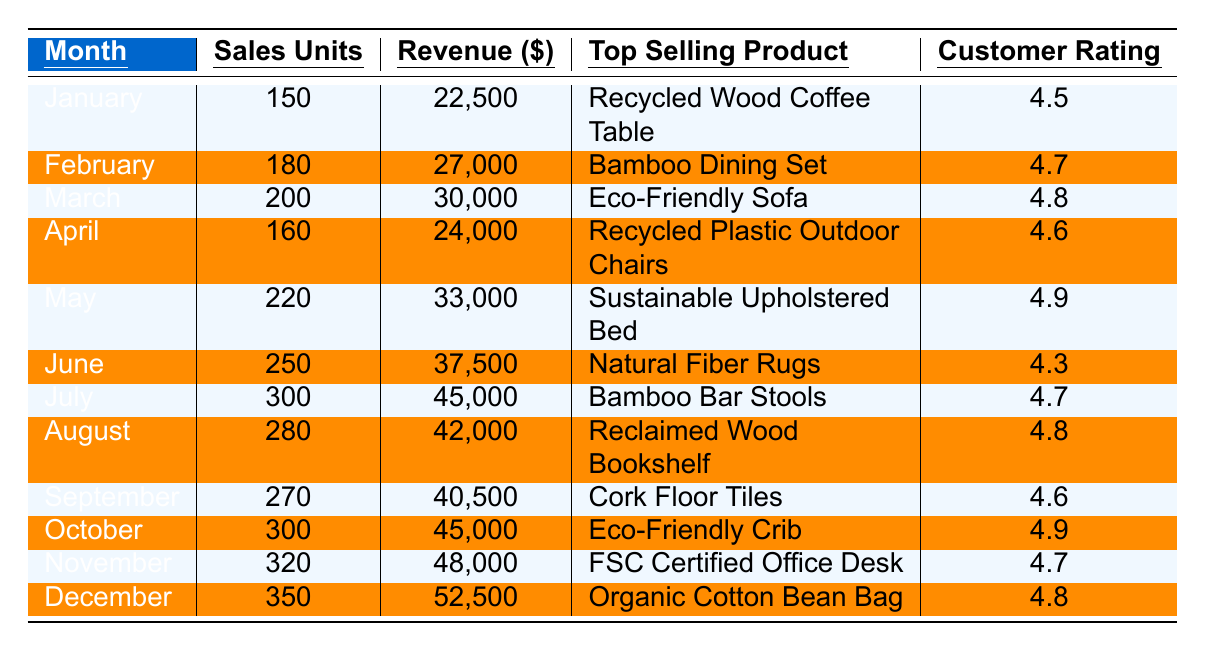What was the top-selling product in December? In December, the top-selling product listed in the table is the "Organic Cotton Bean Bag."
Answer: Organic Cotton Bean Bag Which month had the highest total sales units? The month with the highest total sales units is December with 350 sales units.
Answer: December What was the revenue generated in October? The revenue generated in October was $45,000, as shown in the table.
Answer: $45,000 Calculate the total revenue for the first quarter (January to March). For January: $22,500, February: $27,000, March: $30,000. Summing these values gives: 22,500 + 27,000 + 30,000 = 79,500.
Answer: $79,500 What was the average customer feedback rating for the months of June and July? The customer feedback ratings for June and July are 4.3 and 4.7. The average is (4.3 + 4.7) / 2 = 4.5.
Answer: 4.5 Did sales units ever decrease from the previous month? Yes, sales units decreased from March to April (from 200 to 160 sales units).
Answer: Yes What month showed the most consistent growth in sales units? Examining the sales units month over month, there was consistent growth from May to December, with every month showing an increase from the previous month.
Answer: May to December What was the total number of sales units from August to November? Summing the sales units from August (280), September (270), October (300), and November (320) gives: 280 + 270 + 300 + 320 = 1,170.
Answer: 1,170 Which month had the lowest customer rating? June had the lowest customer rating at 4.3, compared to the other months listed.
Answer: June How much revenue was generated overall for the year? Summing the revenues for all twelve months shows: 22,500 + 27,000 + 30,000 + 24,000 + 33,000 + 37,500 + 45,000 + 42,000 + 40,500 + 45,000 + 48,000 + 52,500 =  509,500.
Answer: $509,500 